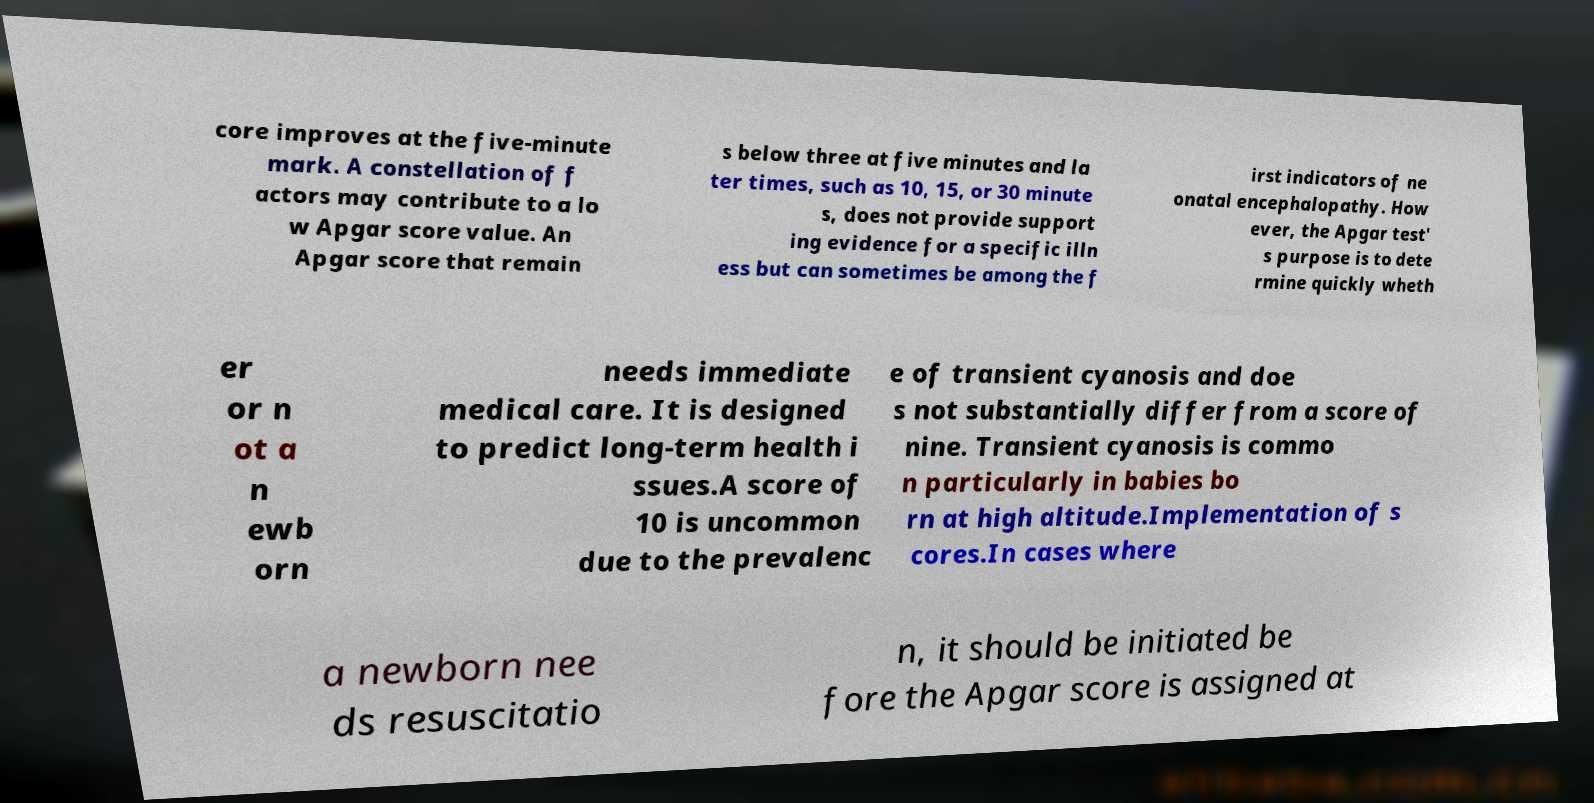For documentation purposes, I need the text within this image transcribed. Could you provide that? core improves at the five-minute mark. A constellation of f actors may contribute to a lo w Apgar score value. An Apgar score that remain s below three at five minutes and la ter times, such as 10, 15, or 30 minute s, does not provide support ing evidence for a specific illn ess but can sometimes be among the f irst indicators of ne onatal encephalopathy. How ever, the Apgar test' s purpose is to dete rmine quickly wheth er or n ot a n ewb orn needs immediate medical care. It is designed to predict long-term health i ssues.A score of 10 is uncommon due to the prevalenc e of transient cyanosis and doe s not substantially differ from a score of nine. Transient cyanosis is commo n particularly in babies bo rn at high altitude.Implementation of s cores.In cases where a newborn nee ds resuscitatio n, it should be initiated be fore the Apgar score is assigned at 